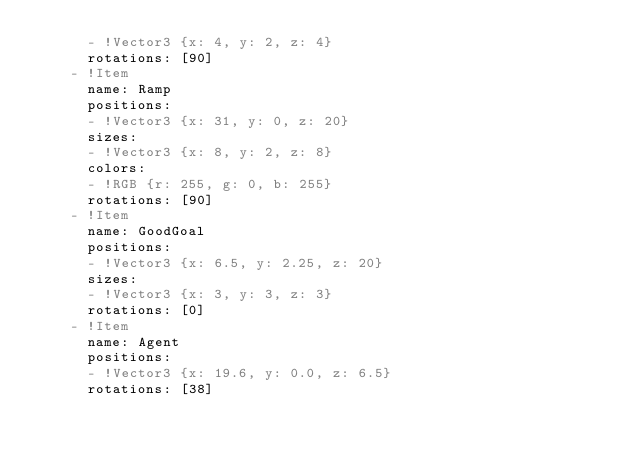Convert code to text. <code><loc_0><loc_0><loc_500><loc_500><_YAML_>      - !Vector3 {x: 4, y: 2, z: 4}
      rotations: [90]
    - !Item 
      name: Ramp 
      positions: 
      - !Vector3 {x: 31, y: 0, z: 20}
      sizes: 
      - !Vector3 {x: 8, y: 2, z: 8}
      colors: 
      - !RGB {r: 255, g: 0, b: 255}
      rotations: [90]
    - !Item 
      name: GoodGoal 
      positions: 
      - !Vector3 {x: 6.5, y: 2.25, z: 20}
      sizes: 
      - !Vector3 {x: 3, y: 3, z: 3}
      rotations: [0]
    - !Item 
      name: Agent 
      positions: 
      - !Vector3 {x: 19.6, y: 0.0, z: 6.5}
      rotations: [38]
</code> 